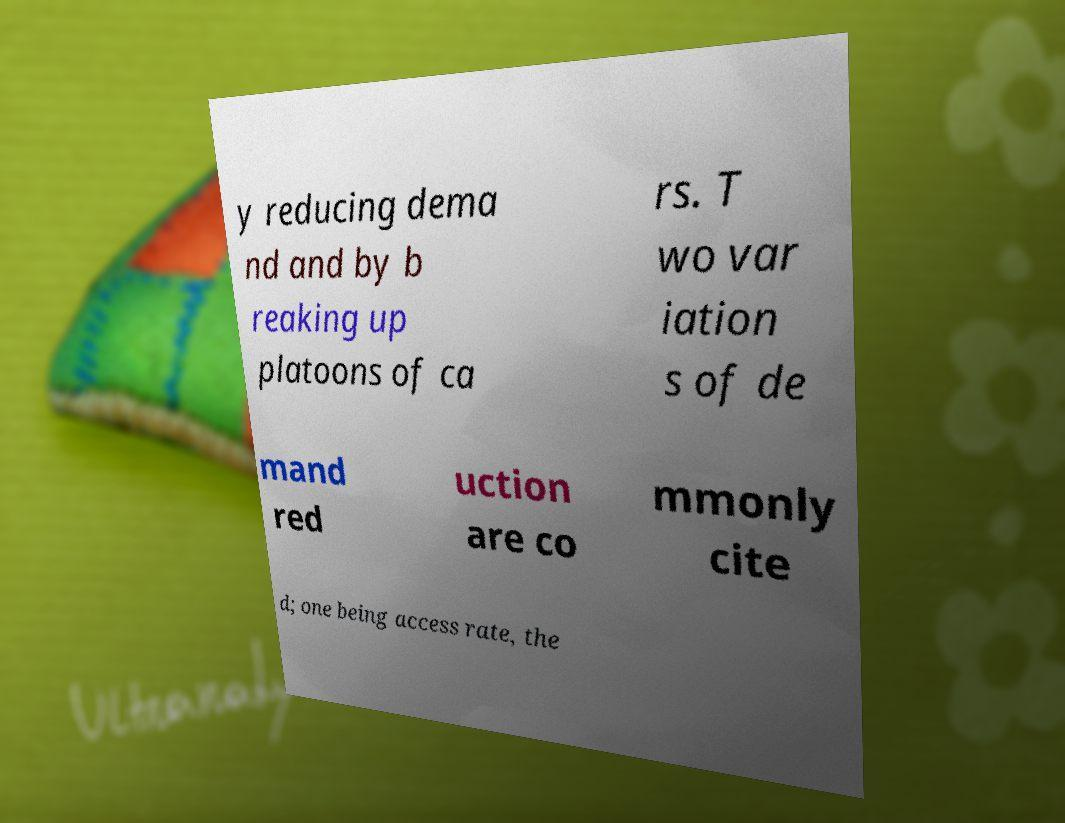Can you read and provide the text displayed in the image?This photo seems to have some interesting text. Can you extract and type it out for me? y reducing dema nd and by b reaking up platoons of ca rs. T wo var iation s of de mand red uction are co mmonly cite d; one being access rate, the 